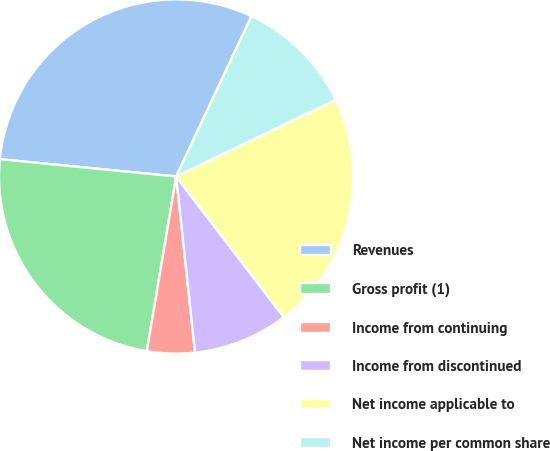Convert chart to OTSL. <chart><loc_0><loc_0><loc_500><loc_500><pie_chart><fcel>Revenues<fcel>Gross profit (1)<fcel>Income from continuing<fcel>Income from discontinued<fcel>Net income applicable to<fcel>Net income per common share<nl><fcel>30.43%<fcel>23.91%<fcel>4.35%<fcel>8.7%<fcel>21.74%<fcel>10.87%<nl></chart> 